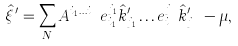Convert formula to latex. <formula><loc_0><loc_0><loc_500><loc_500>\hat { \xi } ^ { \prime } = \sum _ { N } A ^ { i _ { 1 } \dots i _ { N } } e ^ { j _ { 1 } } _ { i _ { 1 } } \hat { k } ^ { \prime } _ { j _ { 1 } } \dots e ^ { j _ { N } } _ { i _ { N } } \hat { k } ^ { \prime } _ { j _ { N } } - \mu ,</formula> 